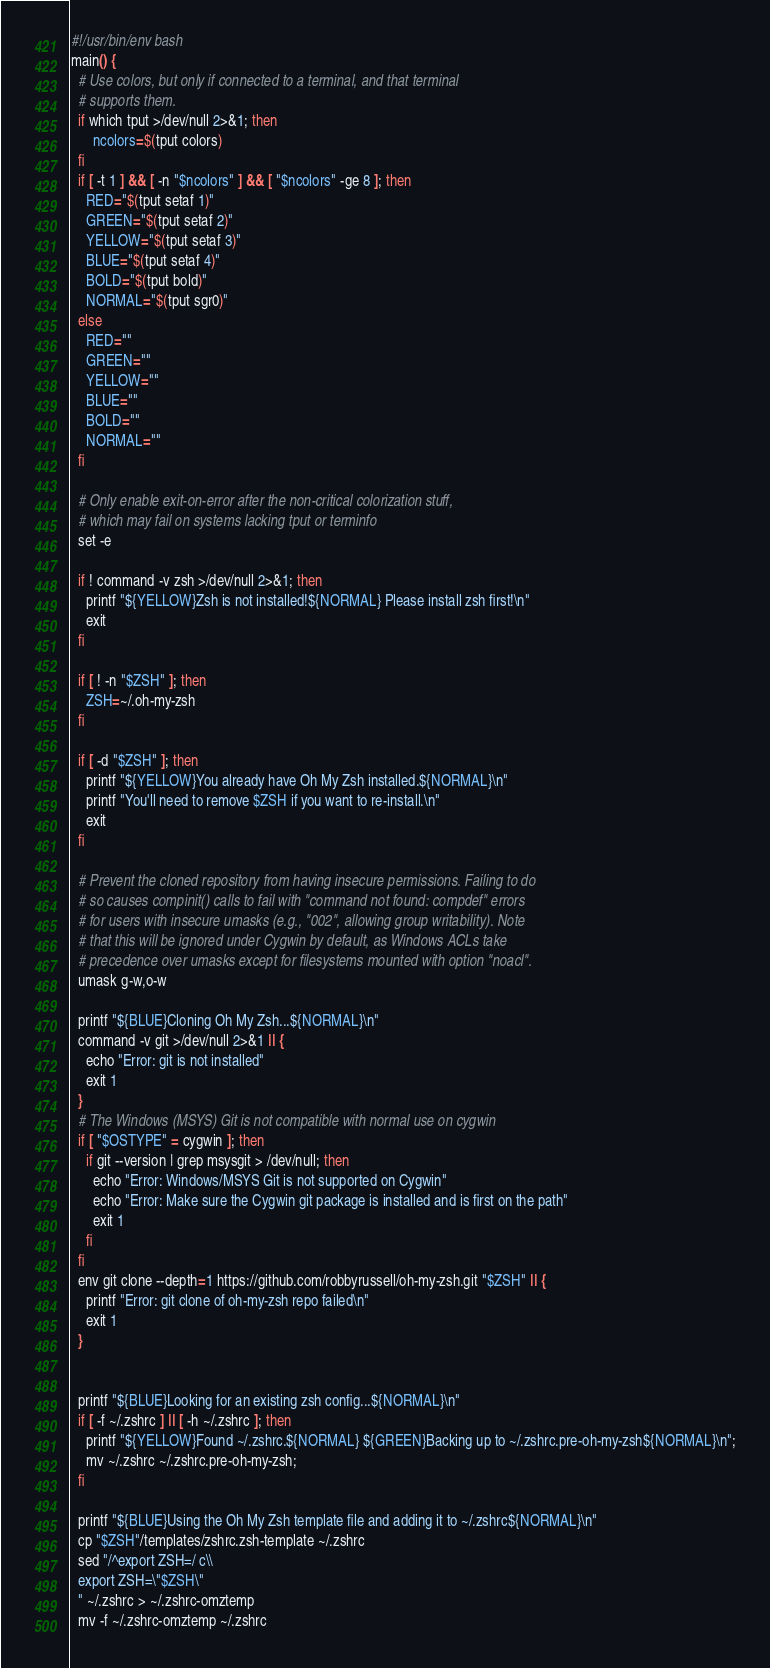<code> <loc_0><loc_0><loc_500><loc_500><_Bash_>#!/usr/bin/env bash
main() {
  # Use colors, but only if connected to a terminal, and that terminal
  # supports them.
  if which tput >/dev/null 2>&1; then
      ncolors=$(tput colors)
  fi
  if [ -t 1 ] && [ -n "$ncolors" ] && [ "$ncolors" -ge 8 ]; then
    RED="$(tput setaf 1)"
    GREEN="$(tput setaf 2)"
    YELLOW="$(tput setaf 3)"
    BLUE="$(tput setaf 4)"
    BOLD="$(tput bold)"
    NORMAL="$(tput sgr0)"
  else
    RED=""
    GREEN=""
    YELLOW=""
    BLUE=""
    BOLD=""
    NORMAL=""
  fi

  # Only enable exit-on-error after the non-critical colorization stuff,
  # which may fail on systems lacking tput or terminfo
  set -e

  if ! command -v zsh >/dev/null 2>&1; then
    printf "${YELLOW}Zsh is not installed!${NORMAL} Please install zsh first!\n"
    exit
  fi

  if [ ! -n "$ZSH" ]; then
    ZSH=~/.oh-my-zsh
  fi

  if [ -d "$ZSH" ]; then
    printf "${YELLOW}You already have Oh My Zsh installed.${NORMAL}\n"
    printf "You'll need to remove $ZSH if you want to re-install.\n"
    exit
  fi

  # Prevent the cloned repository from having insecure permissions. Failing to do
  # so causes compinit() calls to fail with "command not found: compdef" errors
  # for users with insecure umasks (e.g., "002", allowing group writability). Note
  # that this will be ignored under Cygwin by default, as Windows ACLs take
  # precedence over umasks except for filesystems mounted with option "noacl".
  umask g-w,o-w

  printf "${BLUE}Cloning Oh My Zsh...${NORMAL}\n"
  command -v git >/dev/null 2>&1 || {
    echo "Error: git is not installed"
    exit 1
  }
  # The Windows (MSYS) Git is not compatible with normal use on cygwin
  if [ "$OSTYPE" = cygwin ]; then
    if git --version | grep msysgit > /dev/null; then
      echo "Error: Windows/MSYS Git is not supported on Cygwin"
      echo "Error: Make sure the Cygwin git package is installed and is first on the path"
      exit 1
    fi
  fi
  env git clone --depth=1 https://github.com/robbyrussell/oh-my-zsh.git "$ZSH" || {
    printf "Error: git clone of oh-my-zsh repo failed\n"
    exit 1
  }


  printf "${BLUE}Looking for an existing zsh config...${NORMAL}\n"
  if [ -f ~/.zshrc ] || [ -h ~/.zshrc ]; then
    printf "${YELLOW}Found ~/.zshrc.${NORMAL} ${GREEN}Backing up to ~/.zshrc.pre-oh-my-zsh${NORMAL}\n";
    mv ~/.zshrc ~/.zshrc.pre-oh-my-zsh;
  fi

  printf "${BLUE}Using the Oh My Zsh template file and adding it to ~/.zshrc${NORMAL}\n"
  cp "$ZSH"/templates/zshrc.zsh-template ~/.zshrc
  sed "/^export ZSH=/ c\\
  export ZSH=\"$ZSH\"
  " ~/.zshrc > ~/.zshrc-omztemp
  mv -f ~/.zshrc-omztemp ~/.zshrc
</code> 